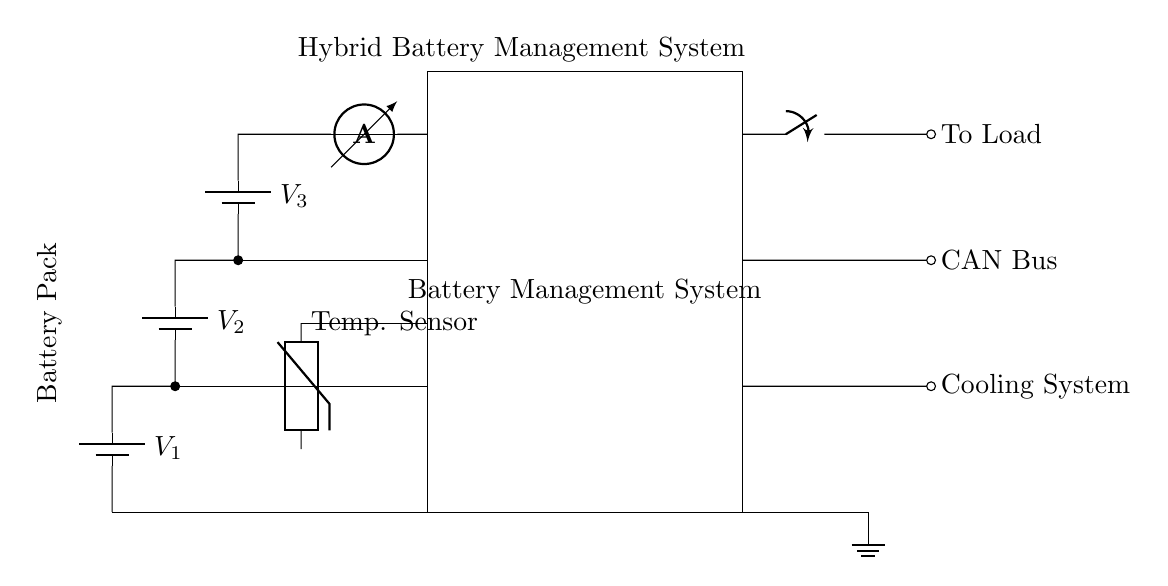What components are part of the battery pack? The battery pack consists of three batteries labeled V1, V2, and V3, connected in series, which represent the voltage sources supplying power.
Answer: V1, V2, V3 What is the purpose of the thermistor in this circuit? The thermistor acts as a temperature sensor, monitoring the temperature within the hybrid battery management system to ensure safe operating conditions.
Answer: Temperature sensor How are the cell voltages monitored? The cell voltages are monitored by connecting the positive terminals of V1, V2, and V3 to corresponding inputs on the Battery Management System, allowing the system to read and manage the voltages.
Answer: Through the BMS connections What type of communication is indicated in the circuit? The circuit indicates the use of a CAN Bus for communication between the Battery Management System and other vehicle systems, making it essential for monitoring and control.
Answer: CAN Bus What happens to the load when the contactor is closed? When the contactor is closed, it completes the circuit, allowing current to flow from the battery pack to the load, which provides power for the vehicle's operations.
Answer: Current flows to load Which component measures the current in the circuit? The ammeter is used to measure the current flowing from the battery pack to the Battery Management System, providing critical data for battery monitoring and management.
Answer: Ammeter How does the cooling system operate in this circuit? The cooling system is connected to the Battery Management System and will activate as needed based on temperature readings, ensuring that the batteries remain within a safe temperature range.
Answer: Activated by temperature control 